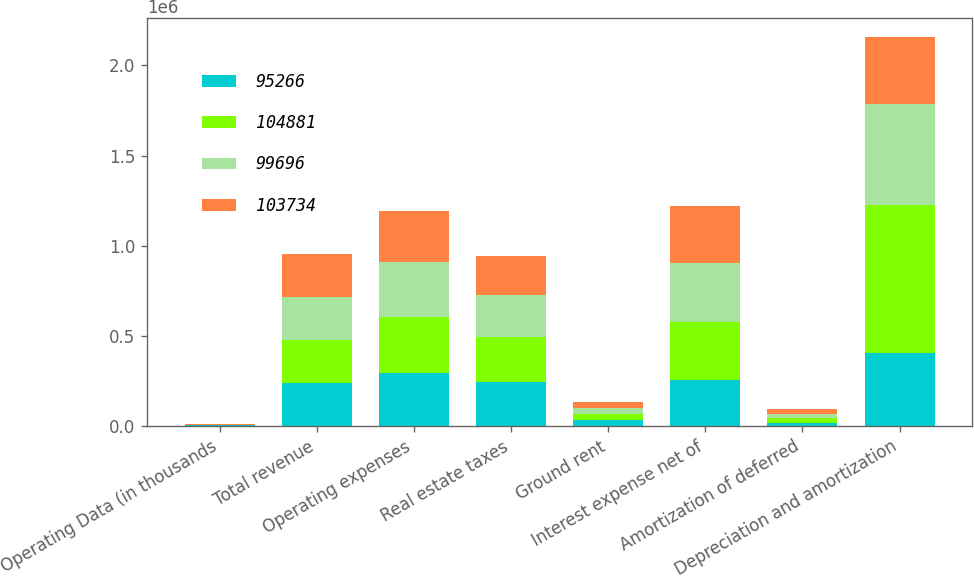Convert chart. <chart><loc_0><loc_0><loc_500><loc_500><stacked_bar_chart><ecel><fcel>Operating Data (in thousands<fcel>Total revenue<fcel>Operating expenses<fcel>Real estate taxes<fcel>Ground rent<fcel>Interest expense net of<fcel>Amortization of deferred<fcel>Depreciation and amortization<nl><fcel>95266<fcel>2017<fcel>238512<fcel>293364<fcel>244323<fcel>33231<fcel>257045<fcel>16498<fcel>403320<nl><fcel>104881<fcel>2016<fcel>238512<fcel>312859<fcel>248388<fcel>33261<fcel>321199<fcel>24564<fcel>821041<nl><fcel>99696<fcel>2015<fcel>238512<fcel>301624<fcel>232702<fcel>32834<fcel>323870<fcel>27348<fcel>560887<nl><fcel>103734<fcel>2014<fcel>238512<fcel>282283<fcel>217843<fcel>32307<fcel>317400<fcel>22377<fcel>371610<nl></chart> 